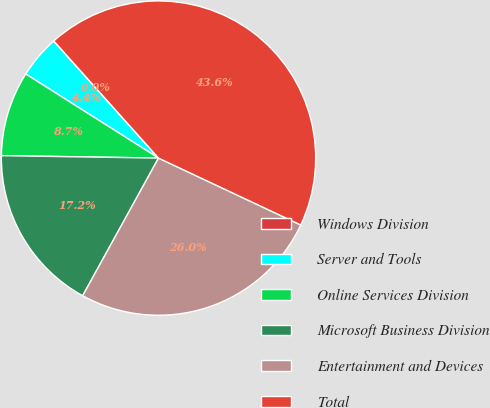Convert chart. <chart><loc_0><loc_0><loc_500><loc_500><pie_chart><fcel>Windows Division<fcel>Server and Tools<fcel>Online Services Division<fcel>Microsoft Business Division<fcel>Entertainment and Devices<fcel>Total<nl><fcel>0.02%<fcel>4.38%<fcel>8.74%<fcel>17.23%<fcel>26.02%<fcel>43.61%<nl></chart> 